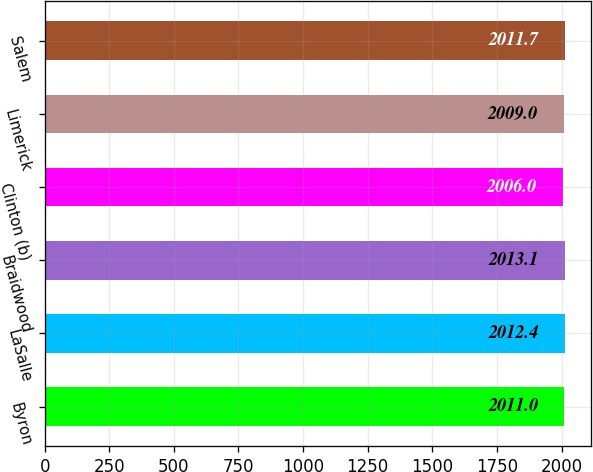Convert chart. <chart><loc_0><loc_0><loc_500><loc_500><bar_chart><fcel>Byron<fcel>LaSalle<fcel>Braidwood<fcel>Clinton (b)<fcel>Limerick<fcel>Salem<nl><fcel>2011<fcel>2012.4<fcel>2013.1<fcel>2006<fcel>2009<fcel>2011.7<nl></chart> 